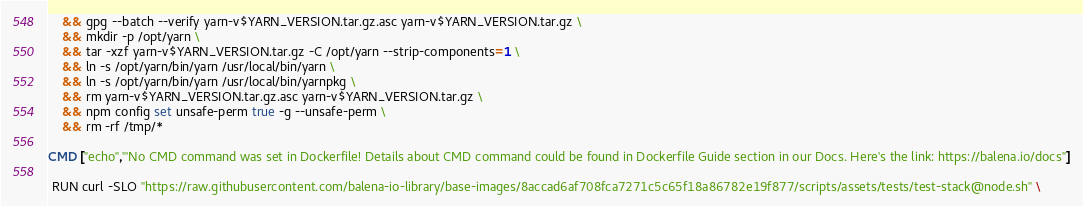<code> <loc_0><loc_0><loc_500><loc_500><_Dockerfile_>	&& gpg --batch --verify yarn-v$YARN_VERSION.tar.gz.asc yarn-v$YARN_VERSION.tar.gz \
	&& mkdir -p /opt/yarn \
	&& tar -xzf yarn-v$YARN_VERSION.tar.gz -C /opt/yarn --strip-components=1 \
	&& ln -s /opt/yarn/bin/yarn /usr/local/bin/yarn \
	&& ln -s /opt/yarn/bin/yarn /usr/local/bin/yarnpkg \
	&& rm yarn-v$YARN_VERSION.tar.gz.asc yarn-v$YARN_VERSION.tar.gz \
	&& npm config set unsafe-perm true -g --unsafe-perm \
	&& rm -rf /tmp/*

CMD ["echo","'No CMD command was set in Dockerfile! Details about CMD command could be found in Dockerfile Guide section in our Docs. Here's the link: https://balena.io/docs"]

 RUN curl -SLO "https://raw.githubusercontent.com/balena-io-library/base-images/8accad6af708fca7271c5c65f18a86782e19f877/scripts/assets/tests/test-stack@node.sh" \</code> 